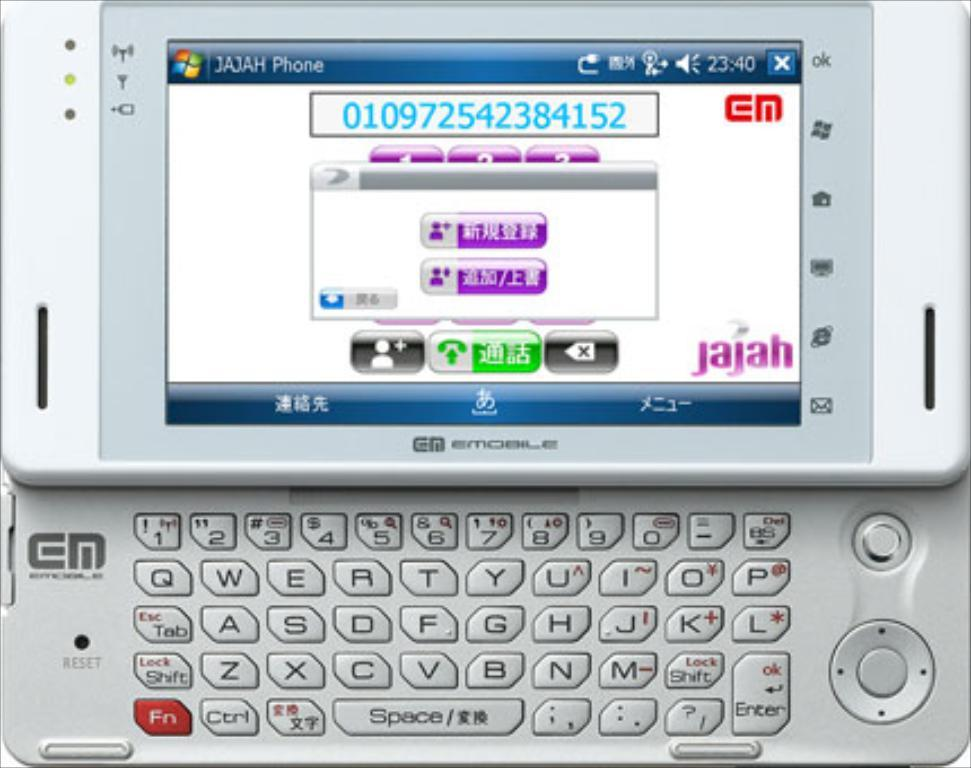Provide a one-sentence caption for the provided image. A JAJAH EMobile phone with a full slide-out keyboard and a screen displaying the number 010972542384152. 